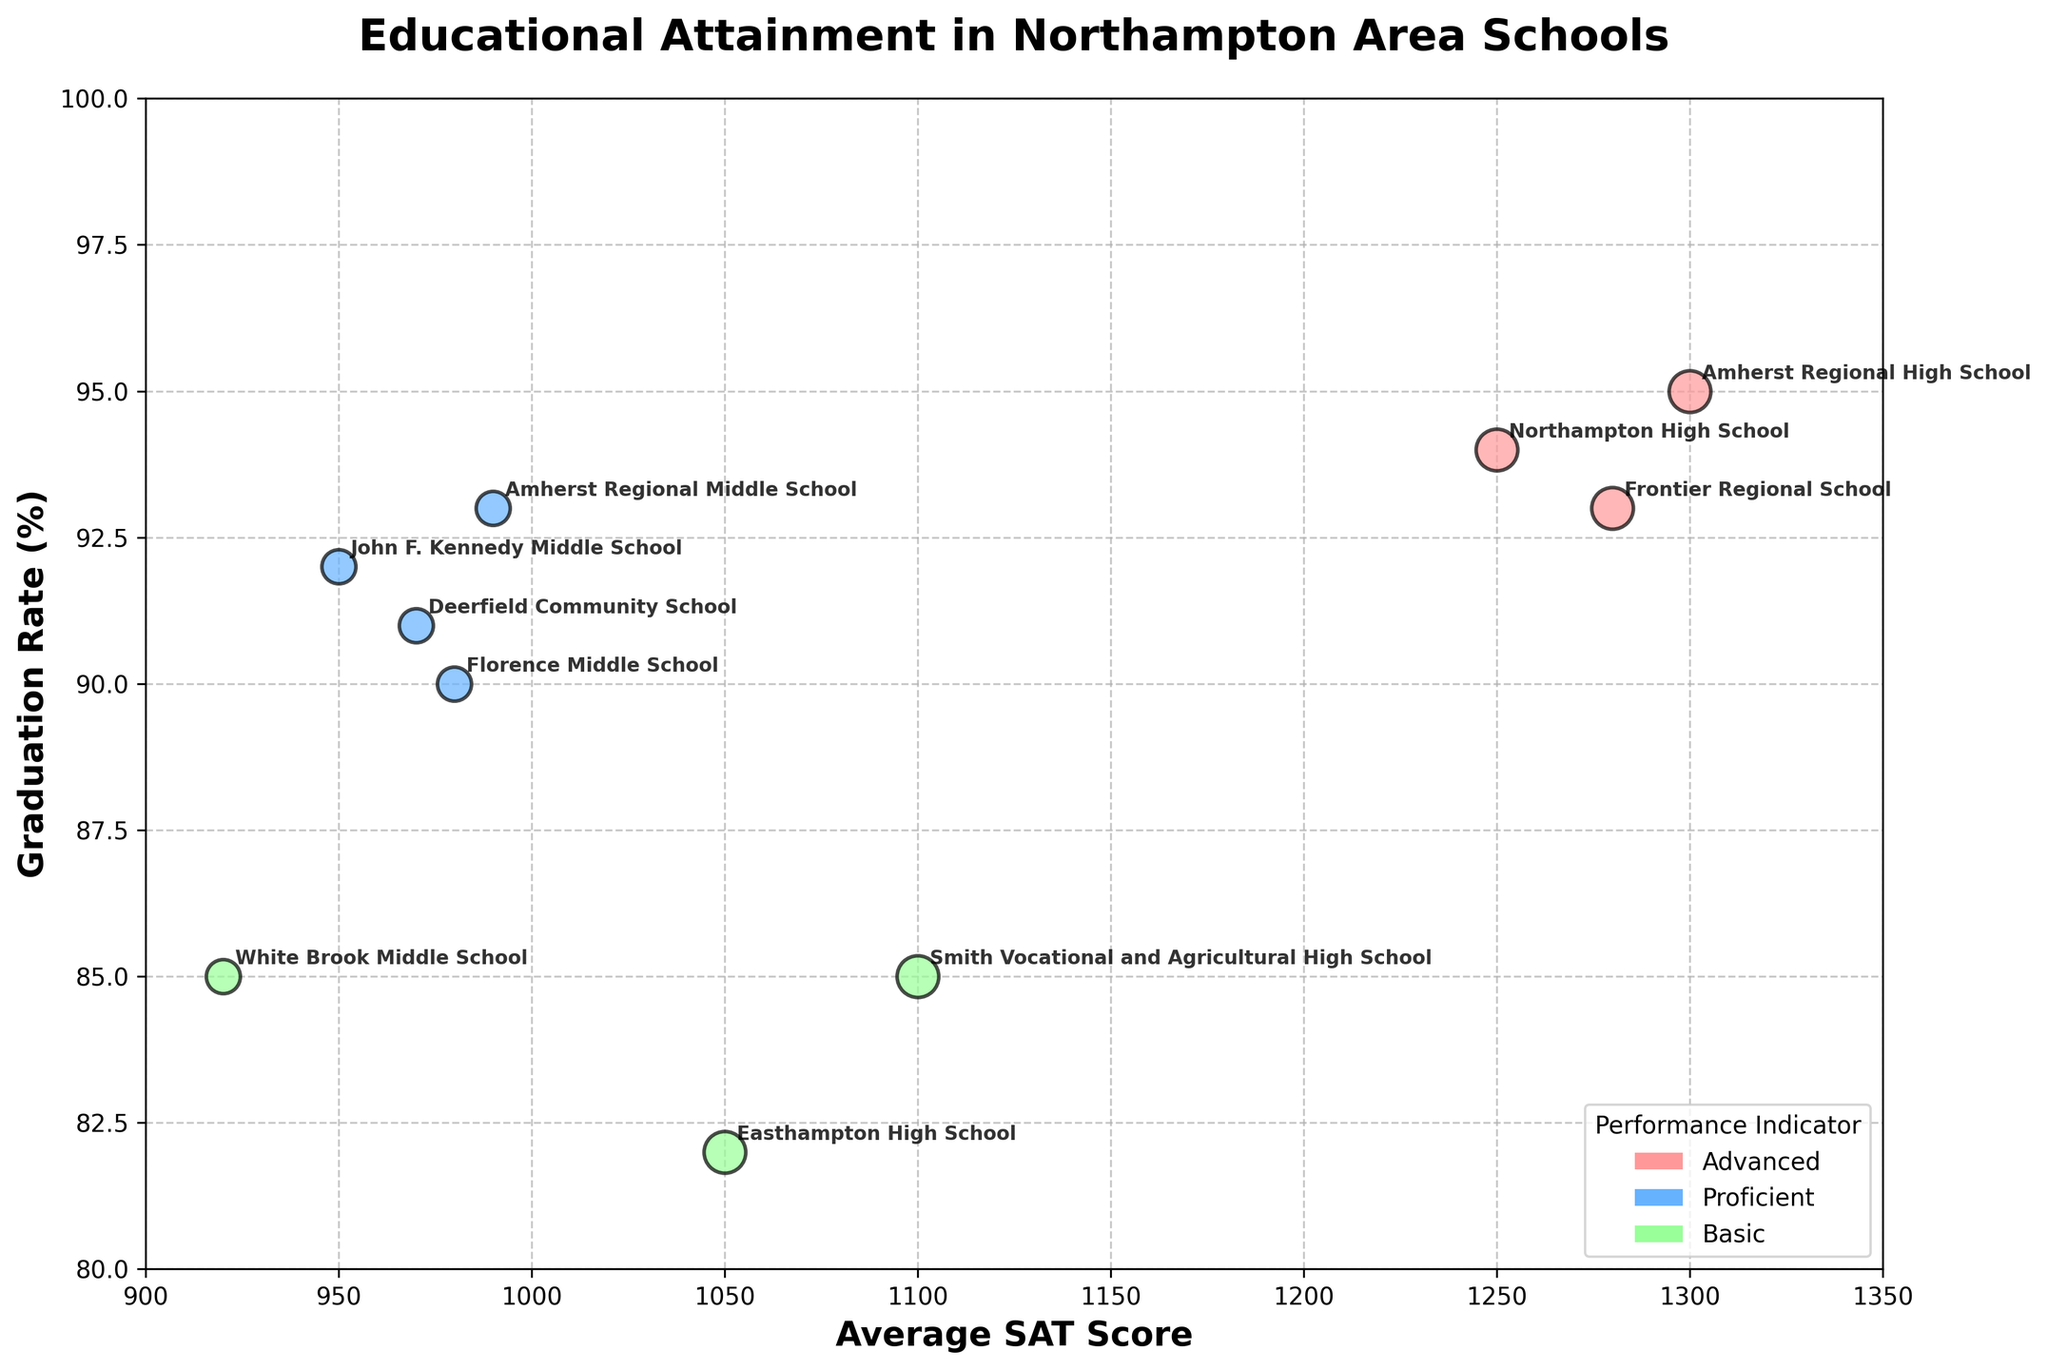What is the title of the figure? The title of the figure can be found at the top of the chart and provides an overview of what the chart represents.
Answer: Educational Attainment in Northampton Area Schools What is the SAT score range for the schools shown in the figure? Look at the x-axis which represents the Average SAT Score. The range can be identified by the minimum and maximum values on this axis.
Answer: 900 to 1350 Which school has the highest Average SAT Score? Find the data point farthest to the right on the x-axis. The school name is labeled near this point.
Answer: Amherst Regional High School What are the sizes of the bubbles and what do they represent? The size of the bubbles corresponds to different school types. High Schools have larger bubbles compared to Middle Schools.
Answer: High School: 300, Middle School: 200 Which performance indicator is represented by the color red? Refer to the color legend in the figure which associates each color with a performance indicator category.
Answer: Advanced What is the average Graduation Rate for all High Schools? Identify and sum all the graduation rates of High Schools: 94, 85, 95, 82, 93. Then divide by the number of High Schools (5). Calculation: (94 + 85 + 95 + 82 + 93)/5.
Answer: 89.8 How does Northampton High School's Attendance Rate compare to Frontier Regional School's Attendance Rate? Locate both schools in the figure and compare their attendance rates by looking at their respective labels.
Answer: Northampton High School: 98, Frontier Regional School: 96 Which neighborhood has the highest number of Advanced Performance Indicator schools? Identify the data points labeled with Advanced and count how many belong to each neighborhood.
Answer: East Side What do the bubbles closer to the upper-right corner of the figure represent? These bubbles have higher values on both the x-axis (SAT Score) and y-axis (Graduation Rate), indicating high-performing schools in both aspects.
Answer: High-performing schools (Higher SAT Scores and Graduation Rates) 